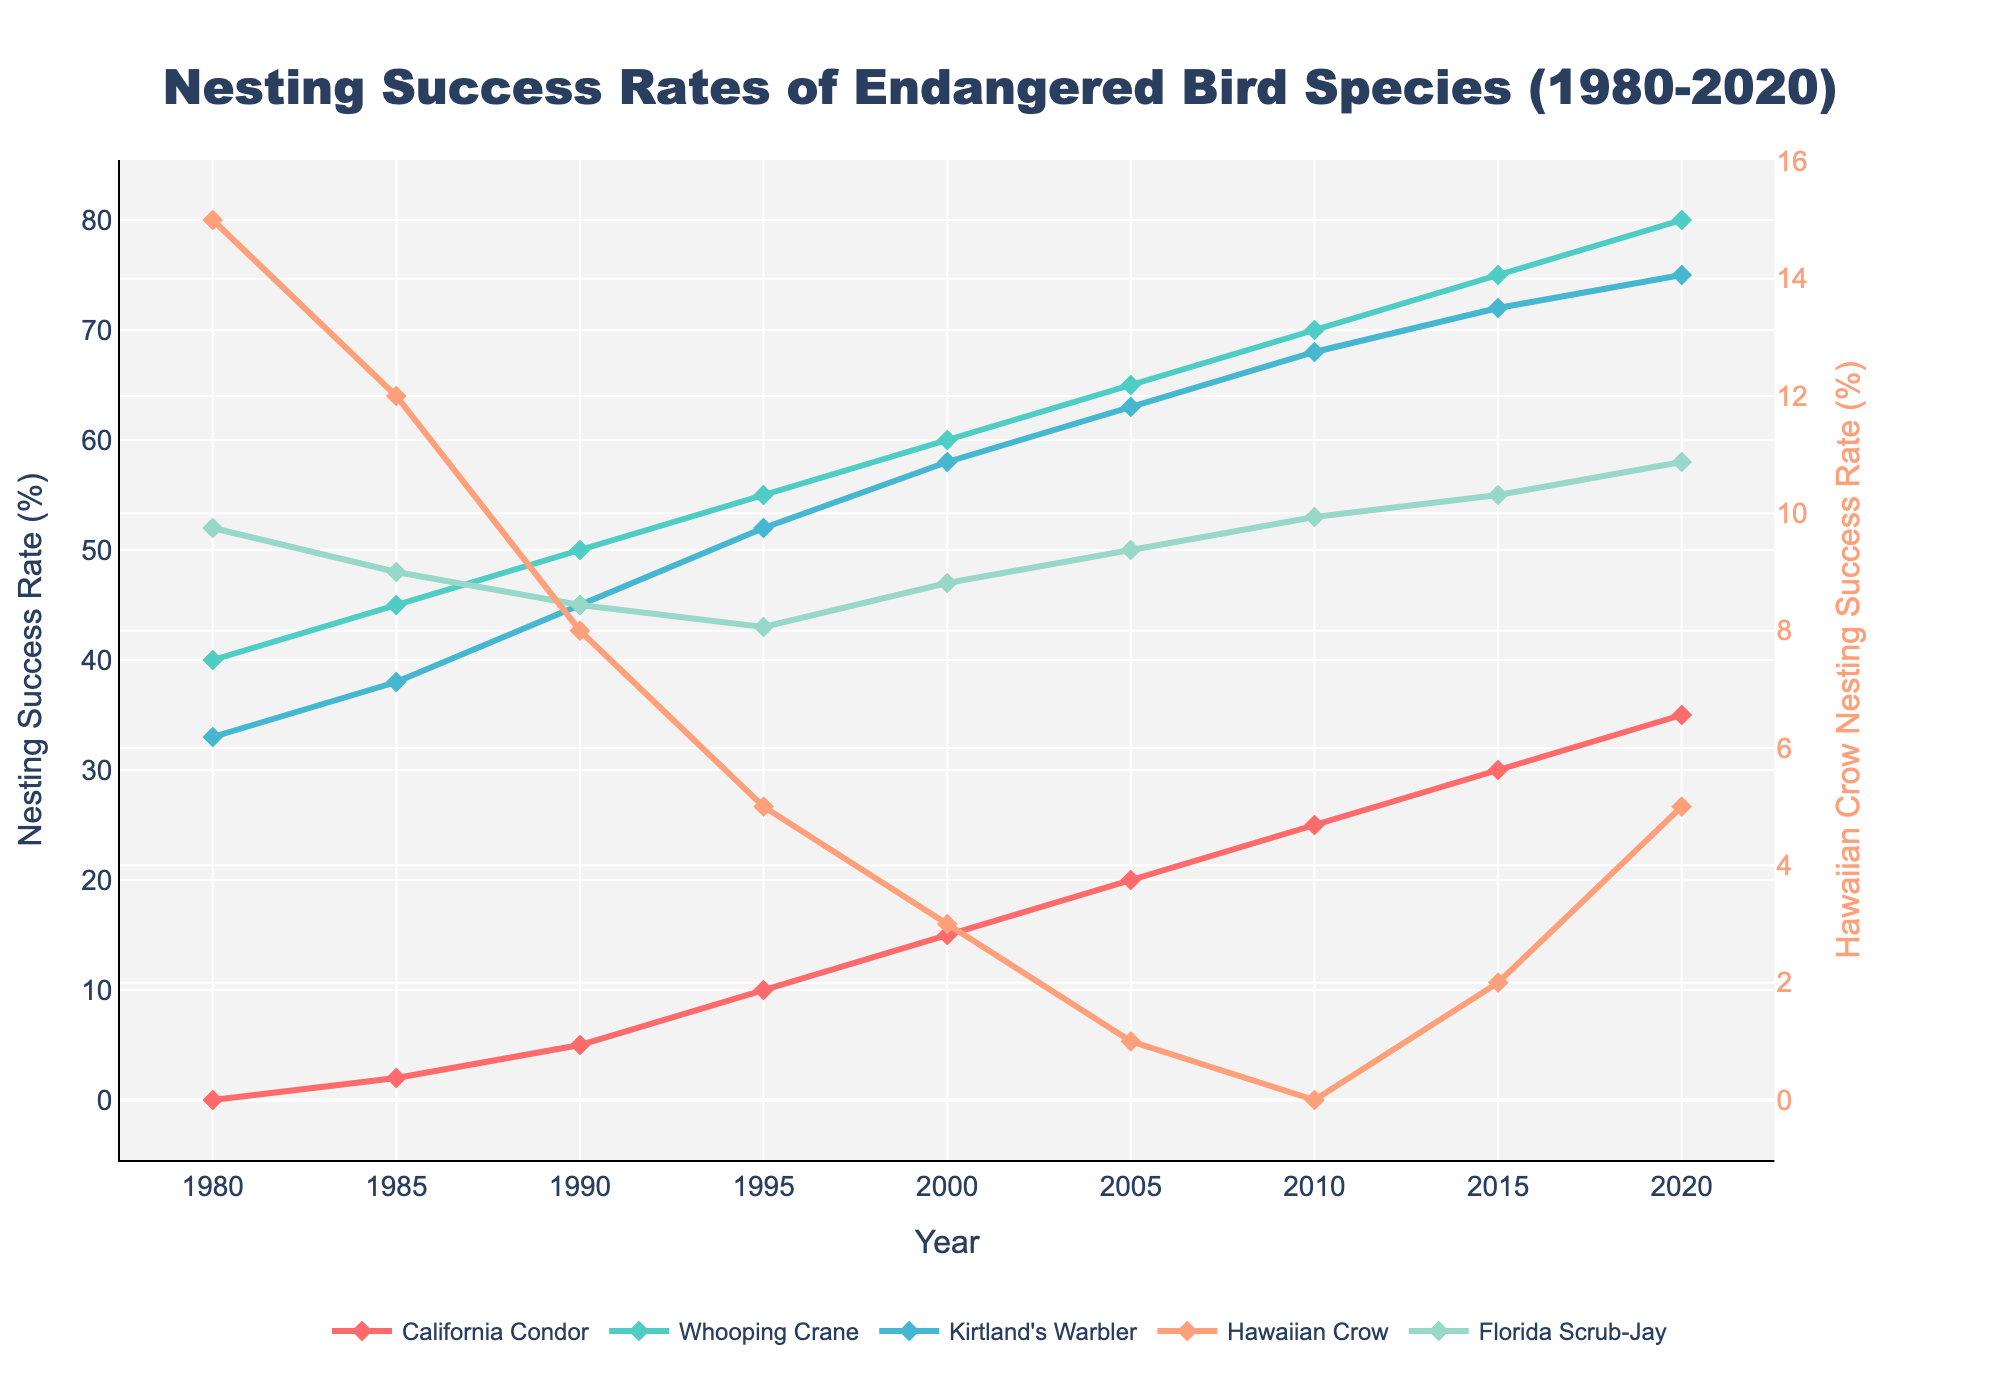what is the average nesting success rate of the Kirtland's Warbler over the years? To find the average, sum the nesting success rates of the Kirtland's Warbler from 1980 to 2020, and then divide by the number of years. The sums are: 33 + 38 + 45 + 52 + 58 + 63 + 68 + 72 + 75 = 504. There are 9 data points, so the average is 504 / 9.
Answer: 56 Compare the success rate of the California Condor and Whooping Crane in 2000. Which species had a higher rate? In 2000, the nesting success rate for the California Condor is 15%, and for the Whooping Crane is 60%. By comparing these values, we determine that the Whooping Crane had a higher nesting success rate.
Answer: Whooping Crane Which species had the lowest nesting success rate in 2010? In 2010, the nesting success rates are: California Condor (25%), Whooping Crane (70%), Kirtland's Warbler (68%), Hawaiian Crow (0%), Florida Scrub-Jay (53%). The Hawaiian Crow had the lowest rate since 0% is the lowest value.
Answer: Hawaiian Crow Determine the increment in the nesting success rate of the California Condor from 1985 to 2005. The nesting success rate for the California Condor in 1985 is 2% and in 2005 it is 20%. The increment is calculated by subtracting the 1985 rate from the 2005 rate: 20 - 2 = 18.
Answer: 18% Which species shows a continuous increase in nesting success rate from 1980 to 2020? Inspect the trends for each species on the graph. The nesting success rates for the California Condor continuously increase every five years from 1980 (0%) to 2020 (35%). Other species do not show a continuous increase.
Answer: California Condor In which year did the nesting success rate of the Whooping Crane first exceed 70%? Check the graph and find the point where the Whooping Crane's nesting success rate surpasses 70%. This occurs first in 2015 (75%).
Answer: 2015 What is the total increase in the nesting success rate of the Florida Scrub-Jay from 1980 to 2020? The nesting success rate for the Florida Scrub-Jay in 1980 is 52% and in 2020 it is 58%. The total increase is calculated as 58 - 52 = 6.
Answer: 6% By how much did the nesting success rate of the Hawaiian Crow change between 1990 and 2010? The nesting success rate for the Hawaiian Crow in 1990 is 8% and in 2010 is 0%. The change is calculated as 0 - 8, resulting in a decrease of 8.
Answer: -8% Which color on the graph represents the Kirtland's Warbler? By checking the described custom color palette, the Kirtland's Warbler is represented by '#45B7D1', which is described as a blue line on the graph.
Answer: Blue Compare the growth rate of the nesting success rates from 1980 to 1995 for the California Condor and the Kirtland's Warbler. Which species had a greater increase over this period? For the California Condor, the increase from 1980 (0%) to 1995 (10%) is 10. For the Kirtland's Warbler, the increase from 1980 (33%) to 1995 (52%) is 19. The Kirtland's Warbler had a greater increase.
Answer: Kirtland's Warbler 